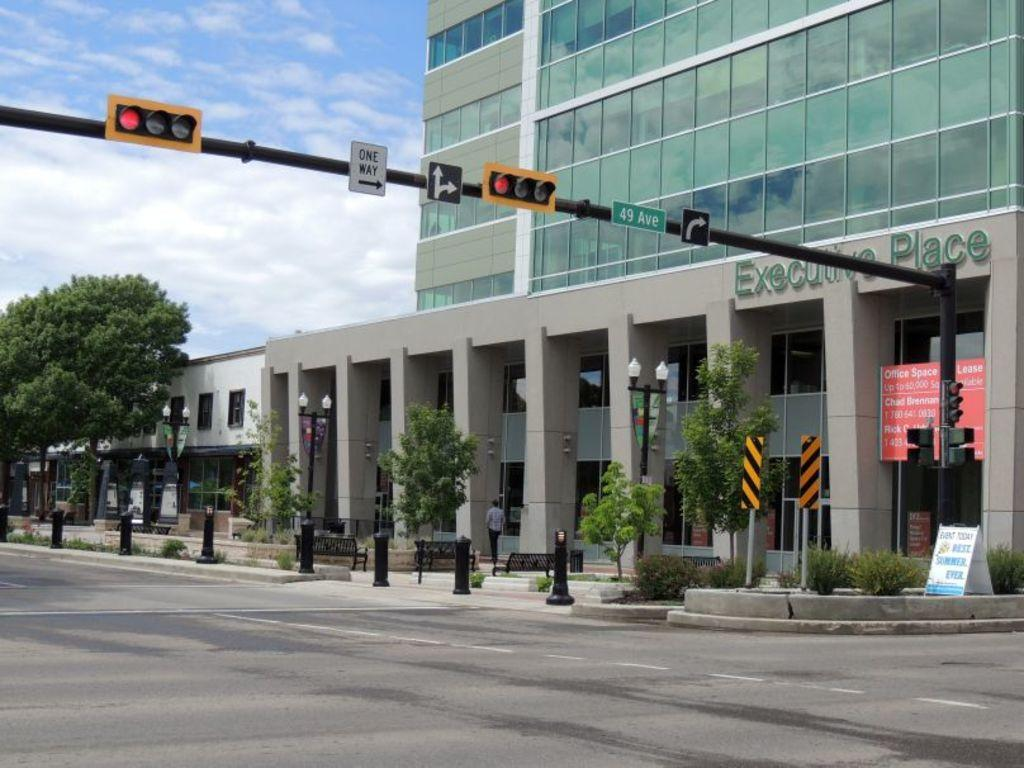<image>
Describe the image concisely. A street sign reading 49th place in front of a building called Executive Place. 